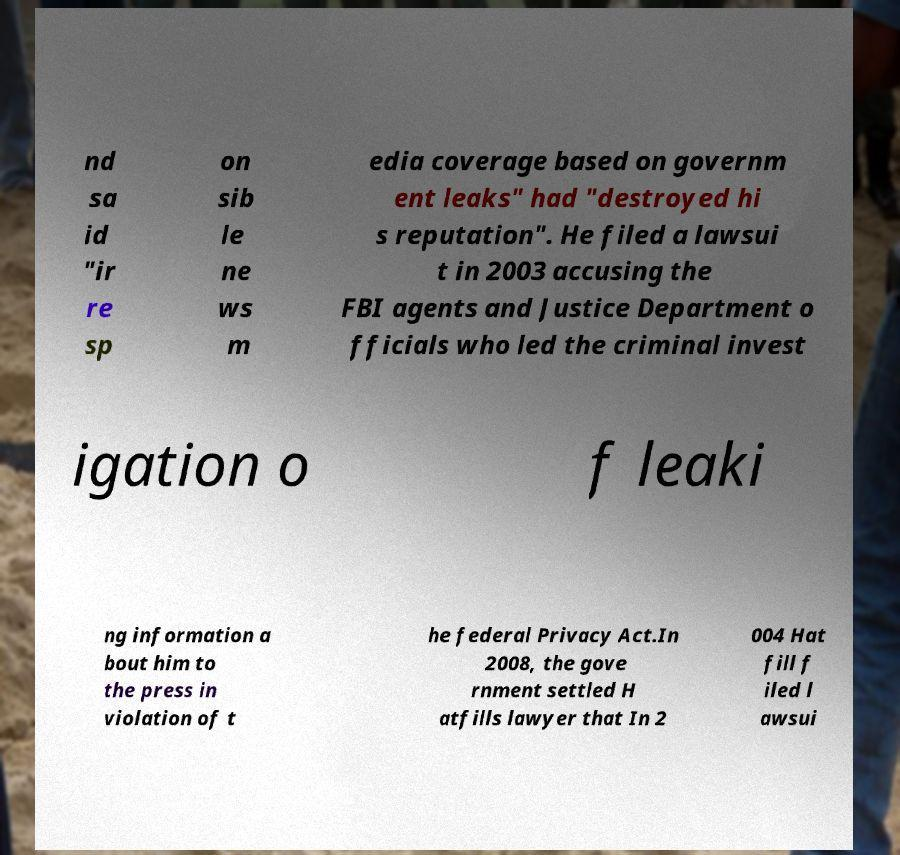Can you accurately transcribe the text from the provided image for me? nd sa id "ir re sp on sib le ne ws m edia coverage based on governm ent leaks" had "destroyed hi s reputation". He filed a lawsui t in 2003 accusing the FBI agents and Justice Department o fficials who led the criminal invest igation o f leaki ng information a bout him to the press in violation of t he federal Privacy Act.In 2008, the gove rnment settled H atfills lawyer that In 2 004 Hat fill f iled l awsui 